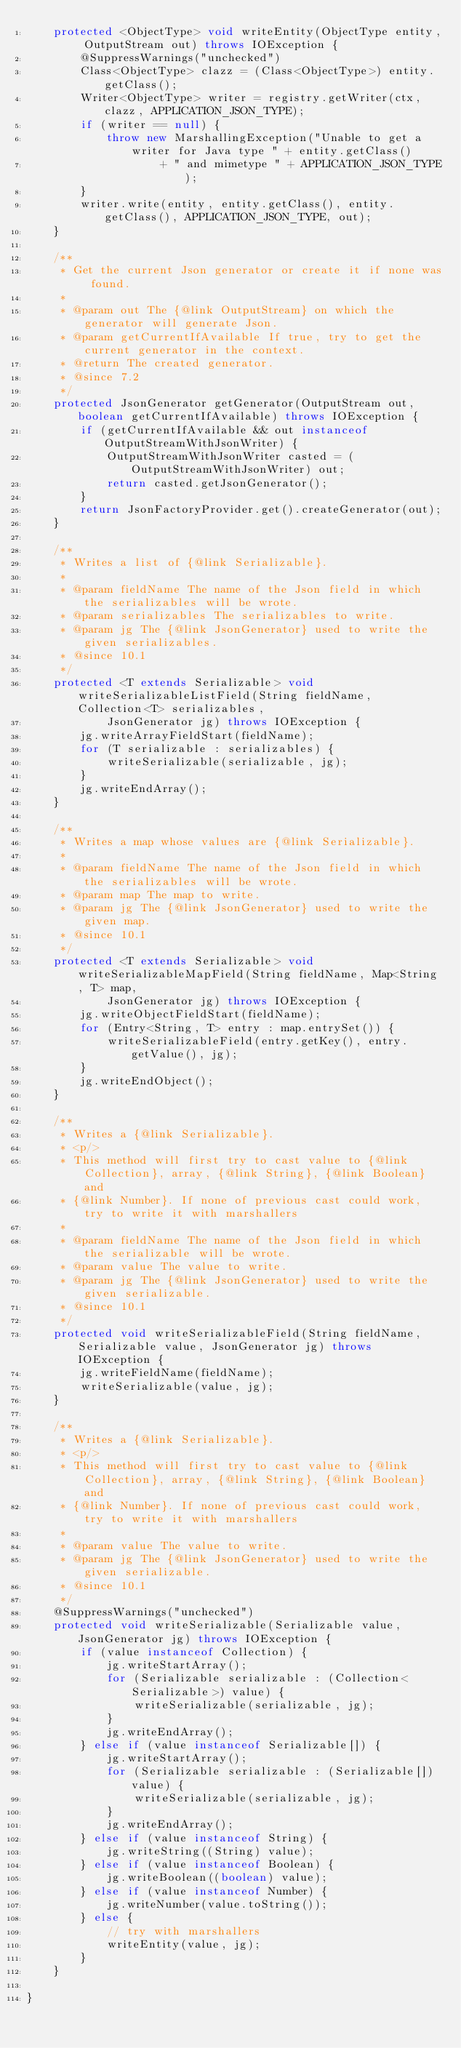<code> <loc_0><loc_0><loc_500><loc_500><_Java_>    protected <ObjectType> void writeEntity(ObjectType entity, OutputStream out) throws IOException {
        @SuppressWarnings("unchecked")
        Class<ObjectType> clazz = (Class<ObjectType>) entity.getClass();
        Writer<ObjectType> writer = registry.getWriter(ctx, clazz, APPLICATION_JSON_TYPE);
        if (writer == null) {
            throw new MarshallingException("Unable to get a writer for Java type " + entity.getClass()
                    + " and mimetype " + APPLICATION_JSON_TYPE);
        }
        writer.write(entity, entity.getClass(), entity.getClass(), APPLICATION_JSON_TYPE, out);
    }

    /**
     * Get the current Json generator or create it if none was found.
     *
     * @param out The {@link OutputStream} on which the generator will generate Json.
     * @param getCurrentIfAvailable If true, try to get the current generator in the context.
     * @return The created generator.
     * @since 7.2
     */
    protected JsonGenerator getGenerator(OutputStream out, boolean getCurrentIfAvailable) throws IOException {
        if (getCurrentIfAvailable && out instanceof OutputStreamWithJsonWriter) {
            OutputStreamWithJsonWriter casted = (OutputStreamWithJsonWriter) out;
            return casted.getJsonGenerator();
        }
        return JsonFactoryProvider.get().createGenerator(out);
    }

    /**
     * Writes a list of {@link Serializable}.
     *
     * @param fieldName The name of the Json field in which the serializables will be wrote.
     * @param serializables The serializables to write.
     * @param jg The {@link JsonGenerator} used to write the given serializables.
     * @since 10.1
     */
    protected <T extends Serializable> void writeSerializableListField(String fieldName, Collection<T> serializables,
            JsonGenerator jg) throws IOException {
        jg.writeArrayFieldStart(fieldName);
        for (T serializable : serializables) {
            writeSerializable(serializable, jg);
        }
        jg.writeEndArray();
    }

    /**
     * Writes a map whose values are {@link Serializable}.
     *
     * @param fieldName The name of the Json field in which the serializables will be wrote.
     * @param map The map to write.
     * @param jg The {@link JsonGenerator} used to write the given map.
     * @since 10.1
     */
    protected <T extends Serializable> void writeSerializableMapField(String fieldName, Map<String, T> map,
            JsonGenerator jg) throws IOException {
        jg.writeObjectFieldStart(fieldName);
        for (Entry<String, T> entry : map.entrySet()) {
            writeSerializableField(entry.getKey(), entry.getValue(), jg);
        }
        jg.writeEndObject();
    }

    /**
     * Writes a {@link Serializable}.
     * <p/>
     * This method will first try to cast value to {@link Collection}, array, {@link String}, {@link Boolean} and
     * {@link Number}. If none of previous cast could work, try to write it with marshallers
     *
     * @param fieldName The name of the Json field in which the serializable will be wrote.
     * @param value The value to write.
     * @param jg The {@link JsonGenerator} used to write the given serializable.
     * @since 10.1
     */
    protected void writeSerializableField(String fieldName, Serializable value, JsonGenerator jg) throws IOException {
        jg.writeFieldName(fieldName);
        writeSerializable(value, jg);
    }

    /**
     * Writes a {@link Serializable}.
     * <p/>
     * This method will first try to cast value to {@link Collection}, array, {@link String}, {@link Boolean} and
     * {@link Number}. If none of previous cast could work, try to write it with marshallers
     *
     * @param value The value to write.
     * @param jg The {@link JsonGenerator} used to write the given serializable.
     * @since 10.1
     */
    @SuppressWarnings("unchecked")
    protected void writeSerializable(Serializable value, JsonGenerator jg) throws IOException {
        if (value instanceof Collection) {
            jg.writeStartArray();
            for (Serializable serializable : (Collection<Serializable>) value) {
                writeSerializable(serializable, jg);
            }
            jg.writeEndArray();
        } else if (value instanceof Serializable[]) {
            jg.writeStartArray();
            for (Serializable serializable : (Serializable[]) value) {
                writeSerializable(serializable, jg);
            }
            jg.writeEndArray();
        } else if (value instanceof String) {
            jg.writeString((String) value);
        } else if (value instanceof Boolean) {
            jg.writeBoolean((boolean) value);
        } else if (value instanceof Number) {
            jg.writeNumber(value.toString());
        } else {
            // try with marshallers
            writeEntity(value, jg);
        }
    }

}
</code> 